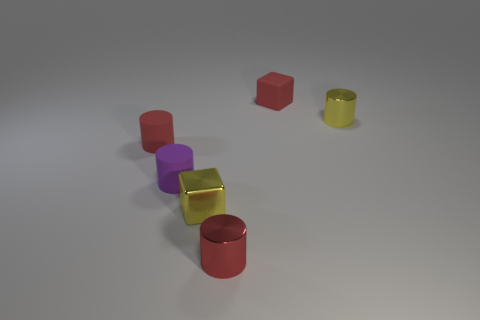Add 2 blue matte blocks. How many objects exist? 8 Subtract all gray cylinders. Subtract all yellow blocks. How many cylinders are left? 4 Subtract all cylinders. How many objects are left? 2 Add 2 tiny red things. How many tiny red things exist? 5 Subtract 1 red blocks. How many objects are left? 5 Subtract all tiny metal things. Subtract all tiny green matte blocks. How many objects are left? 3 Add 4 tiny rubber cylinders. How many tiny rubber cylinders are left? 6 